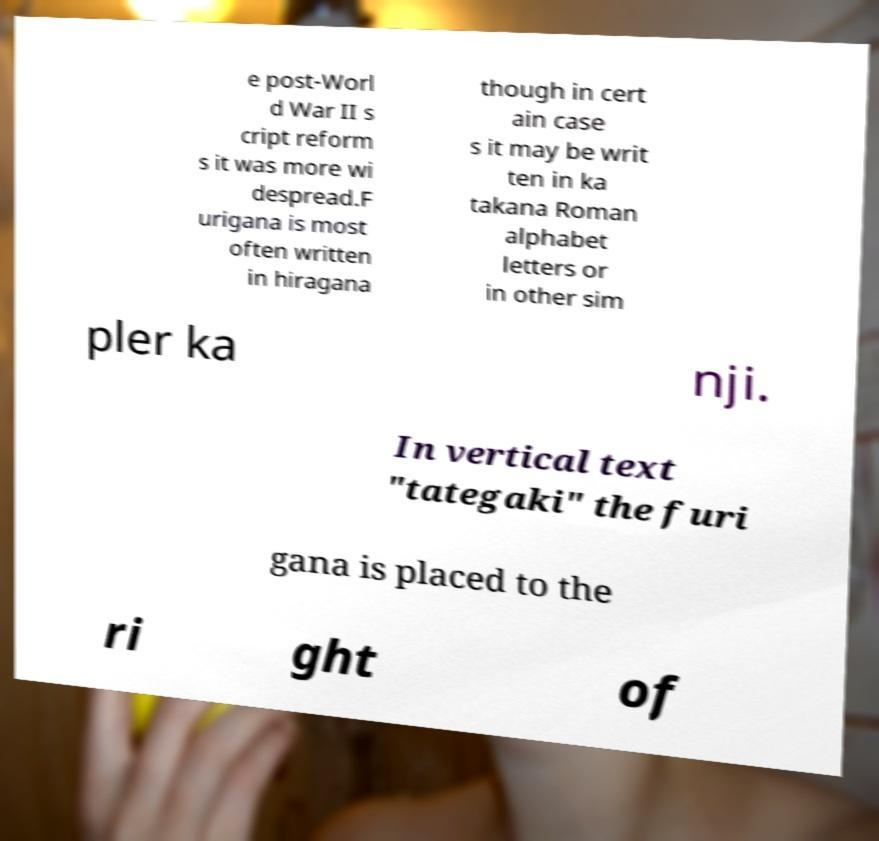What messages or text are displayed in this image? I need them in a readable, typed format. e post-Worl d War II s cript reform s it was more wi despread.F urigana is most often written in hiragana though in cert ain case s it may be writ ten in ka takana Roman alphabet letters or in other sim pler ka nji. In vertical text "tategaki" the furi gana is placed to the ri ght of 